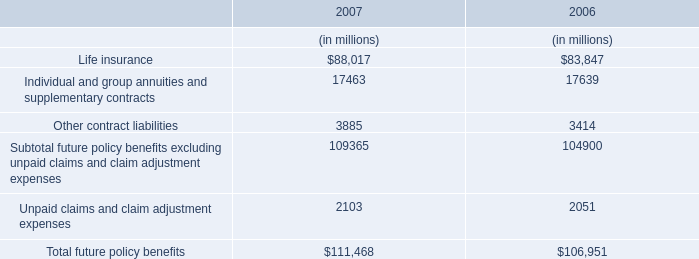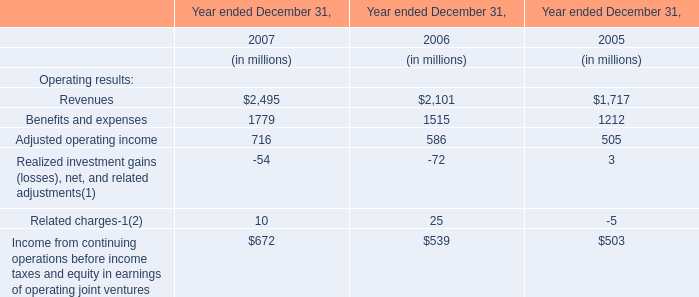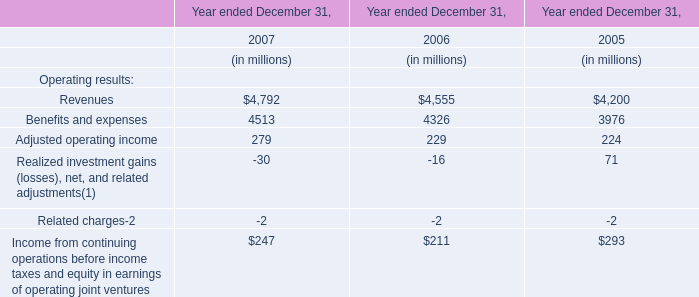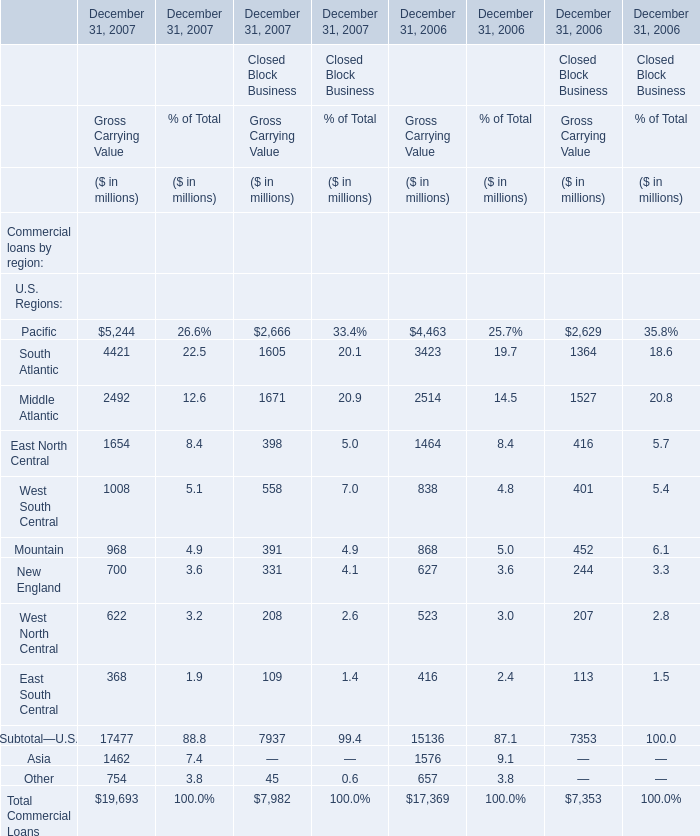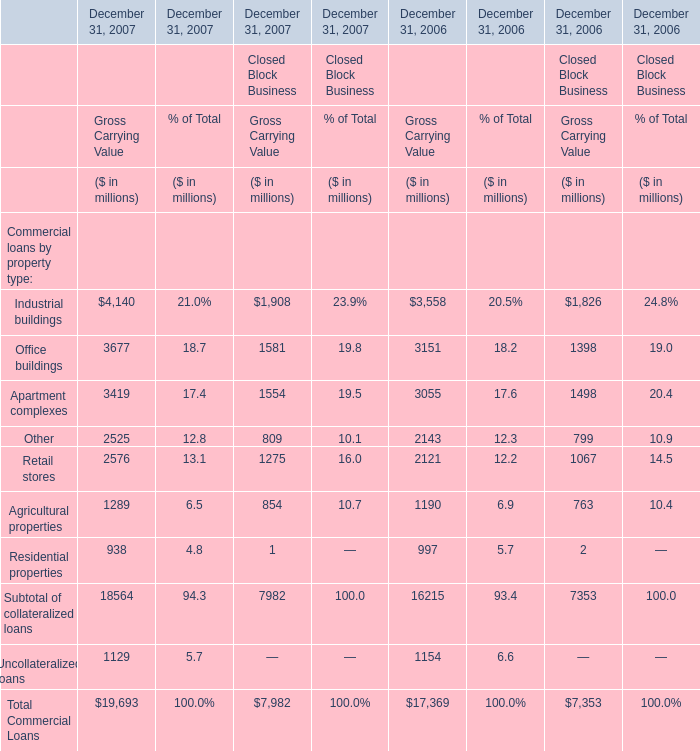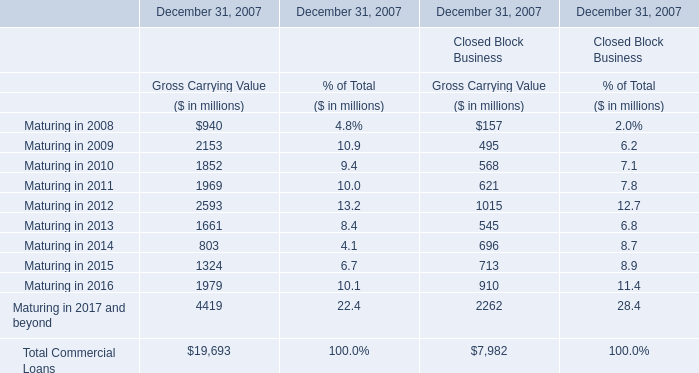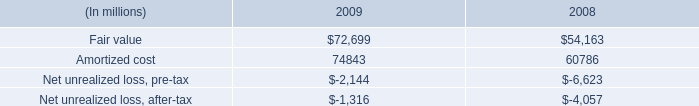what is the percent change of securities between 2008 and 2009? 
Computations: ((72699 - 54163) / 54163)
Answer: 0.34223. 